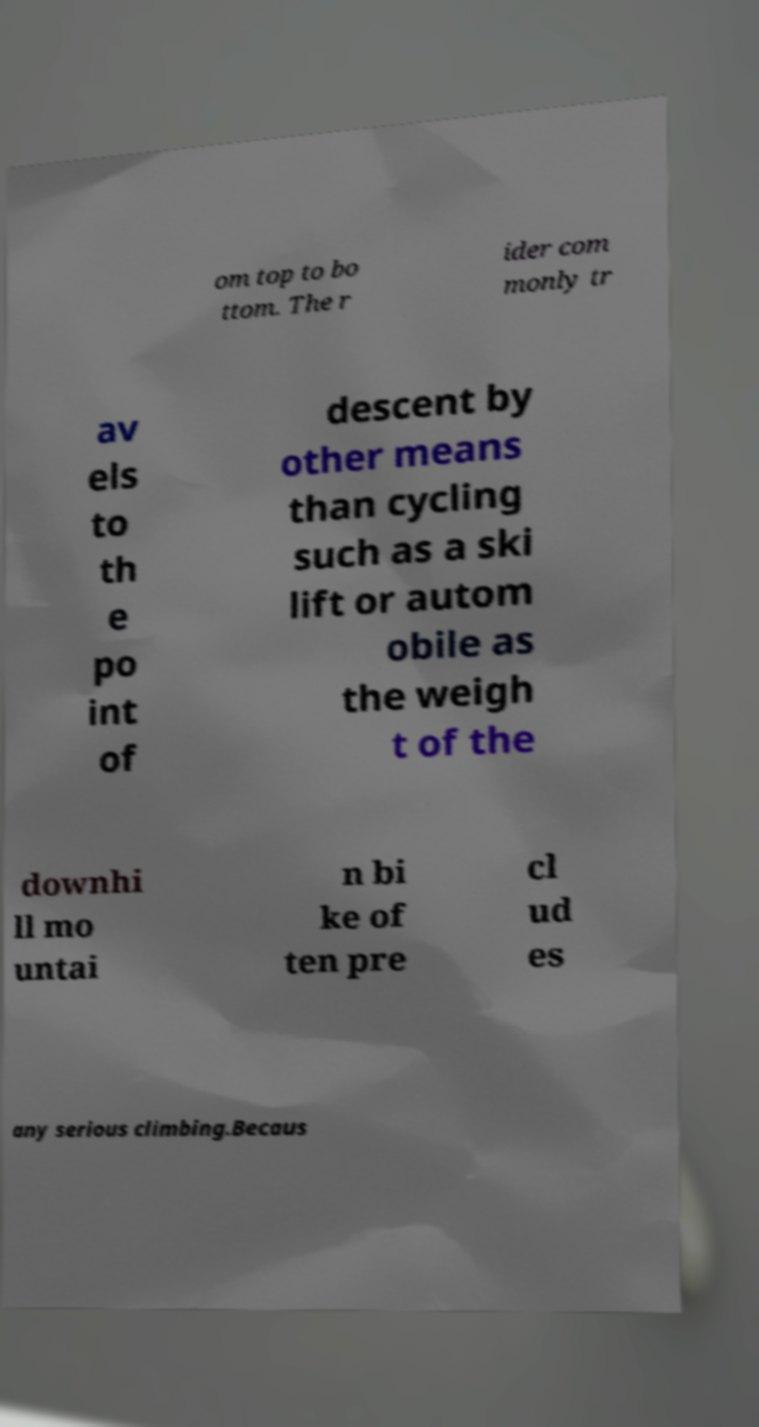What messages or text are displayed in this image? I need them in a readable, typed format. om top to bo ttom. The r ider com monly tr av els to th e po int of descent by other means than cycling such as a ski lift or autom obile as the weigh t of the downhi ll mo untai n bi ke of ten pre cl ud es any serious climbing.Becaus 